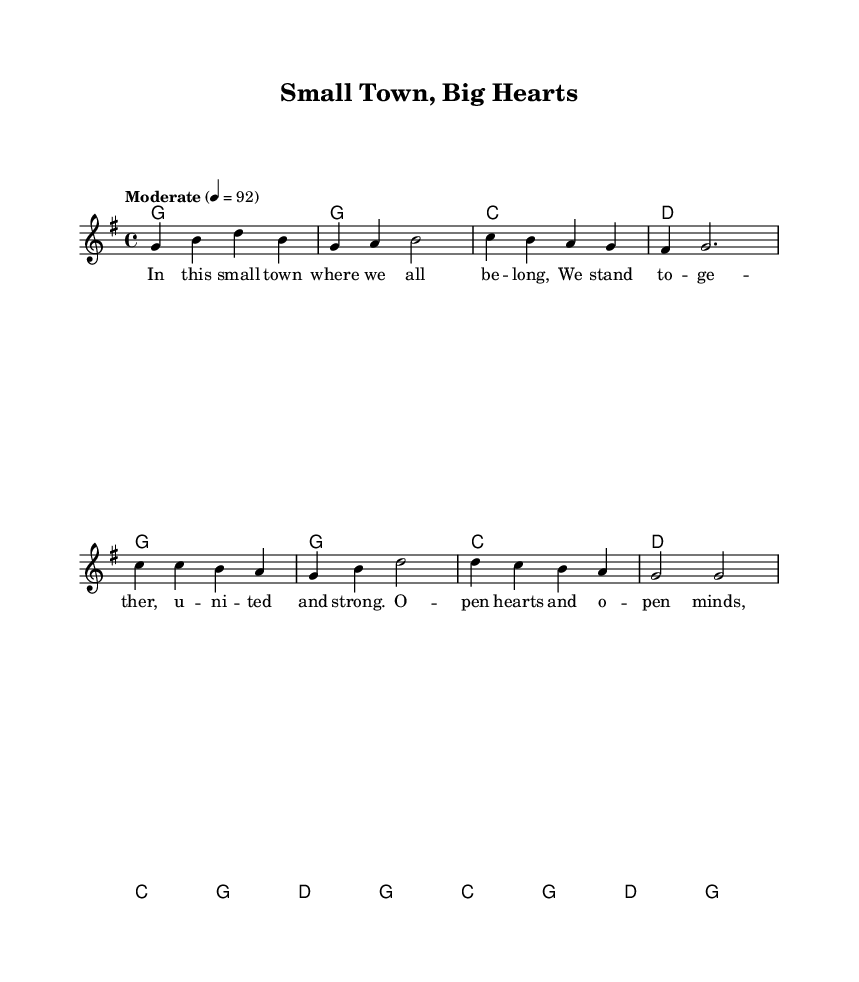What is the key signature of this music? The key signature is G major, which has one sharp (F#). This is determined by looking at the key indicated in the global settings of the sheet music.
Answer: G major What is the time signature of this music? The time signature is 4/4, which means there are four beats per measure. This is specified in the global settings indicated in the code.
Answer: 4/4 What is the tempo marking for this piece? The tempo marking is "Moderate" at a speed of 92 beats per minute. This is indicated in the tempo setting in the global section of the code.
Answer: Moderate 92 How many measures are in the verse of the song? The verse contains 8 measures. This can be counted by breaking down the melody segment where the verse words are provided, identifying each measure separated by vertical lines.
Answer: 8 What phrase describes the theme of the lyrics? The theme focuses on community unity and support, as indicated by the lyrics that emphasize togetherness and acceptance.
Answer: Community unity What are the first two chords of the verse? The first two chords of the verse are G and G. This can be found in the chordmode section for the verse, where the chords are listed in sequence.
Answer: G, G What is the structure of the song based on the sections? The structure of the song consists of verses followed by a chorus, alternating between these sections. This is determined by examining the layout of the melody and corresponding lyrics in the score.
Answer: Verse-Chorus 